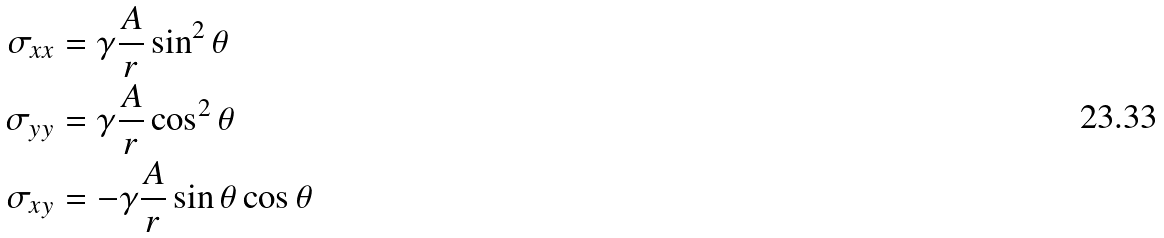Convert formula to latex. <formula><loc_0><loc_0><loc_500><loc_500>\sigma _ { x x } & = \gamma \frac { A } { r } \sin ^ { 2 } \theta \\ \sigma _ { y y } & = \gamma \frac { A } { r } \cos ^ { 2 } \theta \\ \sigma _ { x y } & = - \gamma \frac { A } { r } \sin \theta \cos \theta \\</formula> 